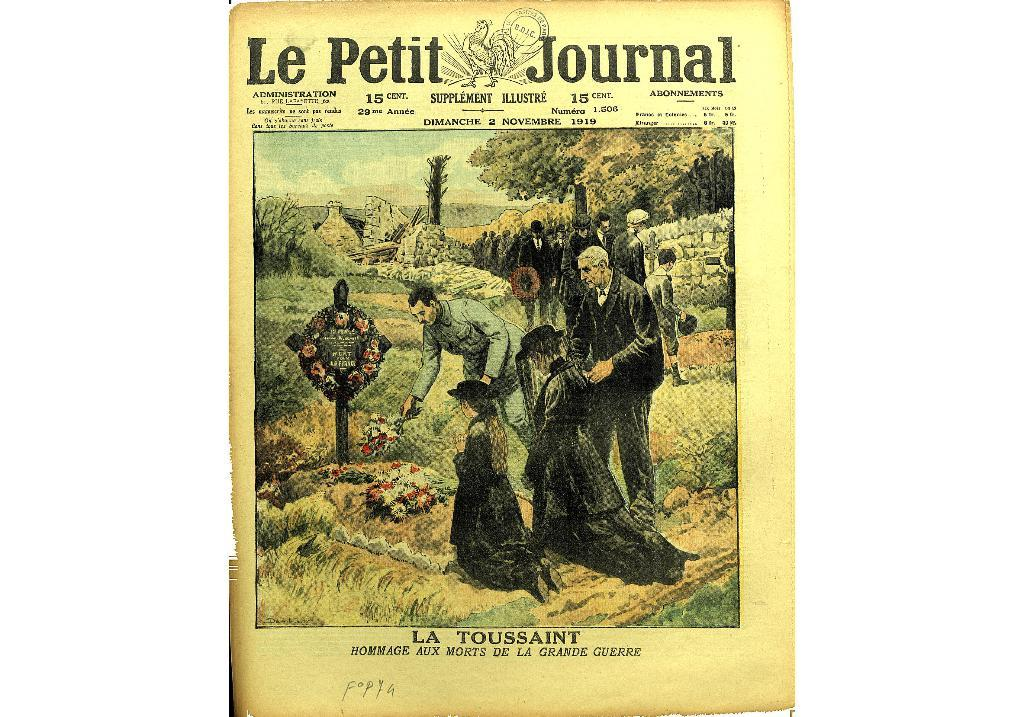Provide a one-sentence caption for the provided image. a page that says 'le petit journal' at the top of it. 